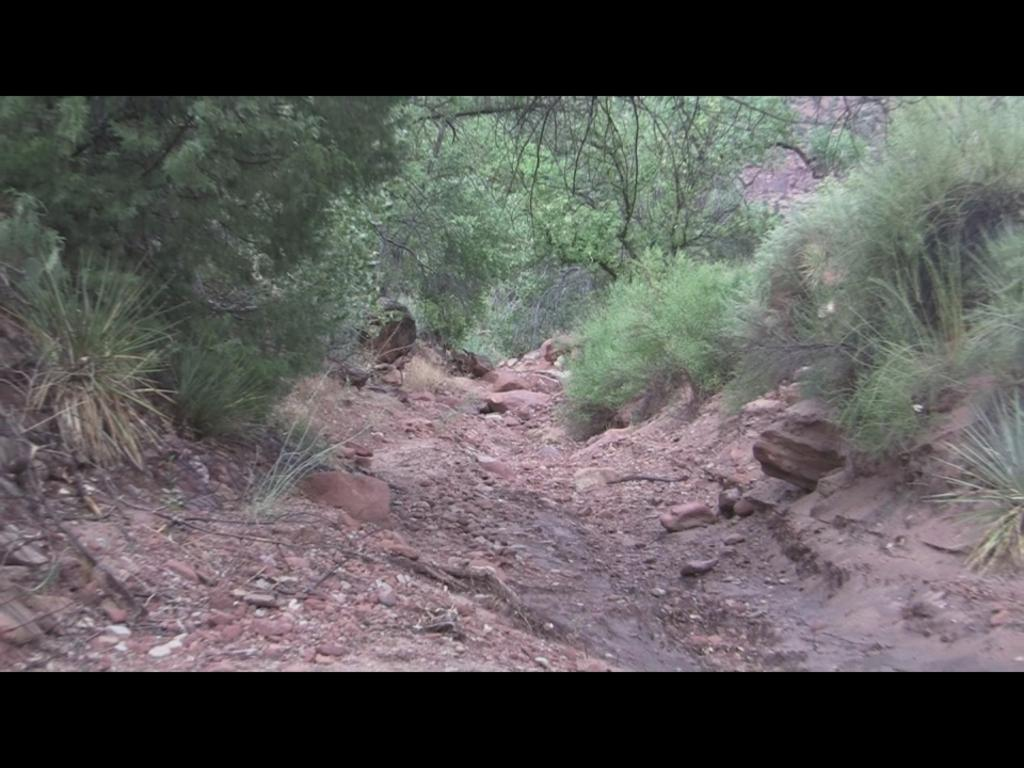What is the main feature in the middle of the image? There is a path in the middle of the image. What type of vegetation can be seen on either side of the path? Trees are present on either side of the path. Can you see any bears playing chess in the image? There are no bears or chess pieces present in the image. 